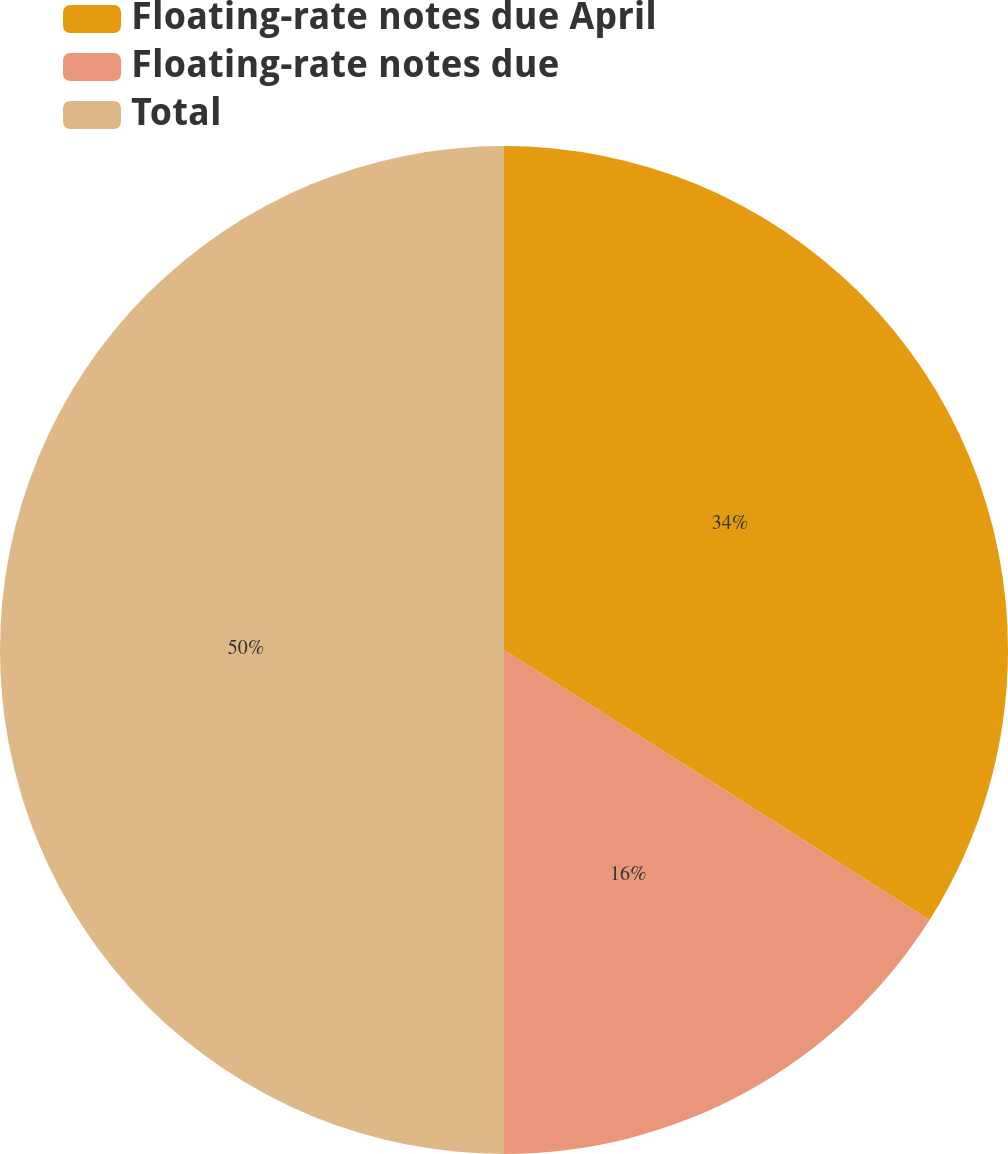<chart> <loc_0><loc_0><loc_500><loc_500><pie_chart><fcel>Floating-rate notes due April<fcel>Floating-rate notes due<fcel>Total<nl><fcel>34.0%<fcel>16.0%<fcel>50.0%<nl></chart> 